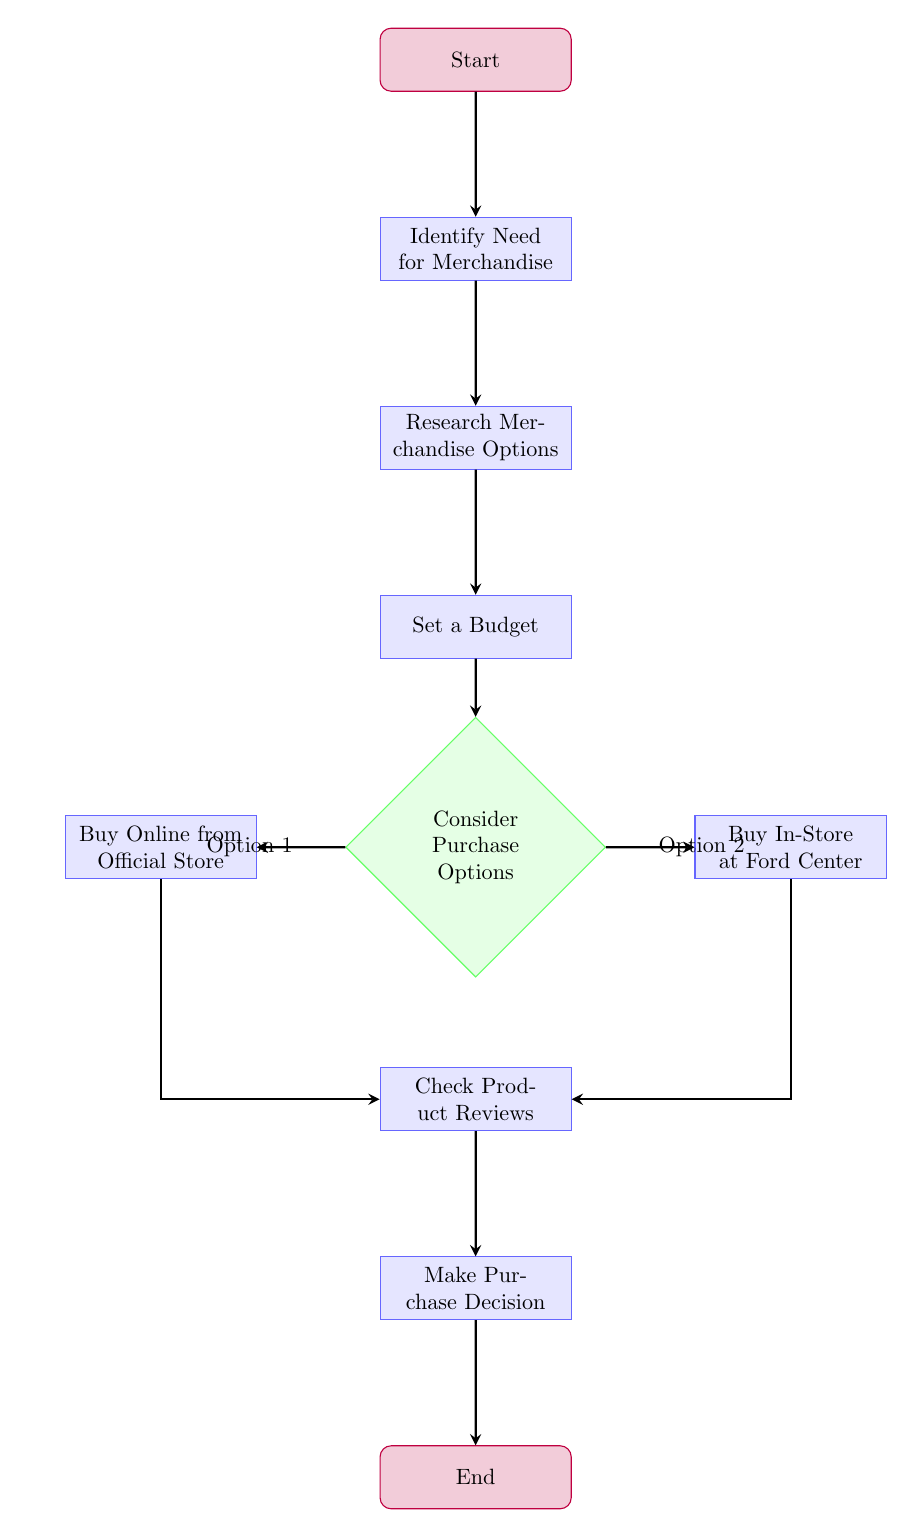What is the first step in the process? The first step in the flow chart is labeled "Start," which leads directly to the next step of identifying the need for merchandise.
Answer: Start How many nodes are in the diagram? The diagram includes a total of 10 nodes, which represent the various steps and decisions in the purchasing process.
Answer: 10 What step comes after setting a budget? After setting a budget, the next step is to consider purchase options, as indicated by the directed flow in the diagram.
Answer: Consider Purchase Options From which two options can purchases be made? The purchase options include "Buy Online from Official Store" and "Buy In-Store at Ford Center," both branching out from the "Consider Purchase Options" node.
Answer: Official Store, Ford Center What should be done before making a purchase decision? Before making a purchase decision, the diagram indicates that one should check product reviews, either online or by asking friends and family for opinions.
Answer: Check Product Reviews How many edges lead out of the 'Consider Purchase Options' node? There are two edges leading out of the 'Consider Purchase Options' node, representing the two different purchasing routes available.
Answer: 2 If a purchase is made online, what is the next step? If a purchase is made online from the official store, the next step is to check online reviews, as indicated in the branching flow from the "Buy Online" node.
Answer: Check Online Reviews What must be satisfied before making the purchase decision? One must be satisfied with the feedback received from checking reviews in order to proceed to the purchasing decision step.
Answer: Satisfied with feedback What is the final step in this decision-making process? The final step in the decision-making process is to complete the transaction, which is labeled as "End" in the flow chart.
Answer: End 